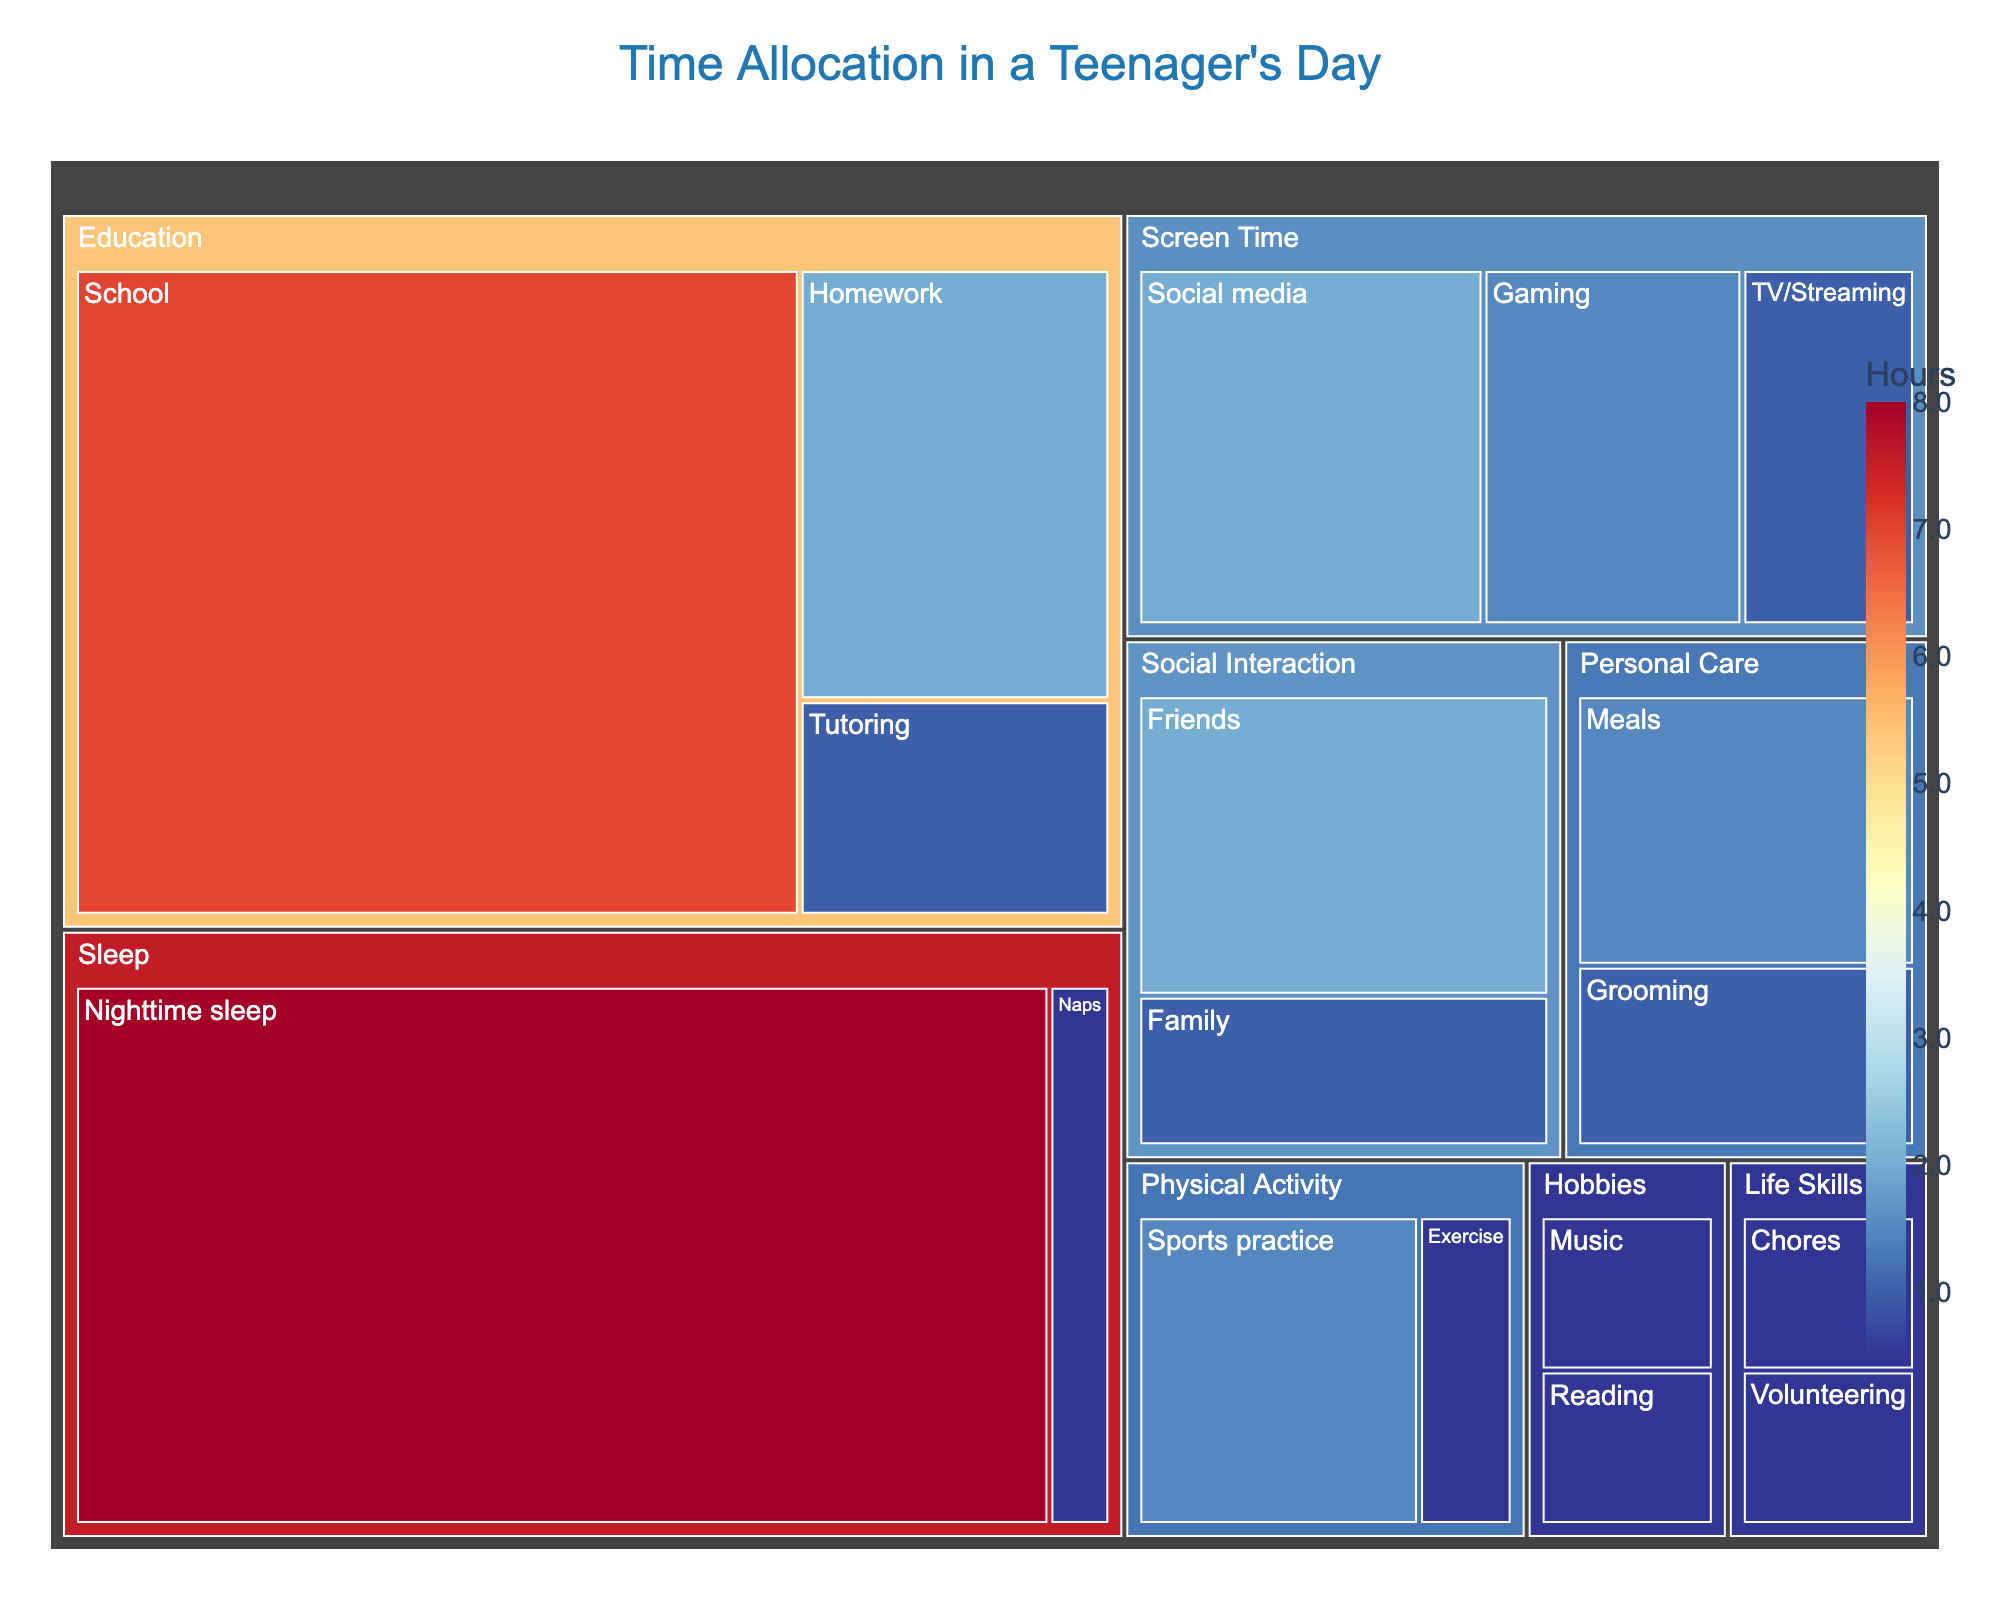What's the title of the figure? The title is displayed prominently at the top center of the figure in a larger font size and different color. By reading this, one can understand the primary topic of the treemap.
Answer: "Time Allocation in a Teenager's Day" Which category has the largest time allocation? The largest time allocation can be identified by looking at the size of the blocks. The biggest block will represent the category with the highest number of hours.
Answer: Sleep How many hours does the teenager spend on education? Sum up the hours spent on all subcategories of Education (School, Homework, and Tutoring). These are: 7 (School) + 2 (Homework) + 1 (Tutoring).
Answer: 10 What is the total time spent on Screen Time activities? The total time for Screen Time activities can be found by summing the hours of its subcategories (Social media, Gaming, and TV/Streaming): 2 + 1.5 + 1.
Answer: 4.5 Which category contains the most subcategories? Identify which category on the treemap is divided into the most smaller blocks. This indicates the number of subcategories within each primary category.
Answer: Education Does the time spent with friends or family take more hours? Compare the hours allocated to Friends and Family subcategories under Social Interaction. Friends has 2 hours whereas Family has 1 hour.
Answer: Friends What's the total time allocated to physical activities? Add the hours spent on both Sports practice and Exercise under Physical Activity. These are: 1.5 (Sports practice) + 0.5 (Exercise).
Answer: 2 Which activity has the least time allocation? The smallest block on the treemap represents the activity with the least amount of time allocated.
Answer: Chores or Volunteering How many hours are allocated to Personal Care? Sum up the hours for Grooming and Meals under the Personal Care category: 1 (Grooming) + 1.5 (Meals).
Answer: 2.5 Compare the time allocation between Hobbies and Life Skills. Which takes more hours? Sum the hours for both categories. For Hobbies: Reading (0.5) + Music (0.5) = 1. For Life Skills: Chores (0.5) + Volunteering (0.5) = 1. Both categories have the same total time allocation of 1 hour.
Answer: Equal 